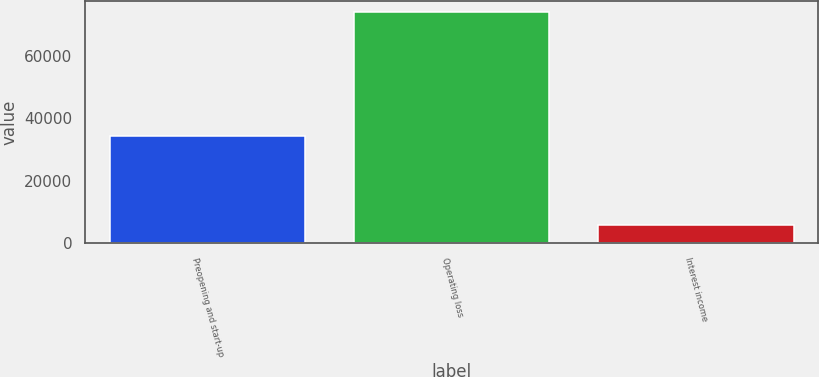<chart> <loc_0><loc_0><loc_500><loc_500><bar_chart><fcel>Preopening and start-up<fcel>Operating loss<fcel>Interest income<nl><fcel>34420<fcel>73767<fcel>5808<nl></chart> 